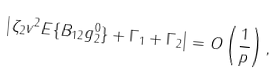Convert formula to latex. <formula><loc_0><loc_0><loc_500><loc_500>\left | \zeta _ { 2 } v ^ { 2 } { E } \{ B _ { 1 2 } g ^ { 0 } _ { 2 } \} + \Gamma _ { 1 } + \Gamma _ { 2 } \right | = O \left ( \frac { 1 } { p } \right ) ,</formula> 